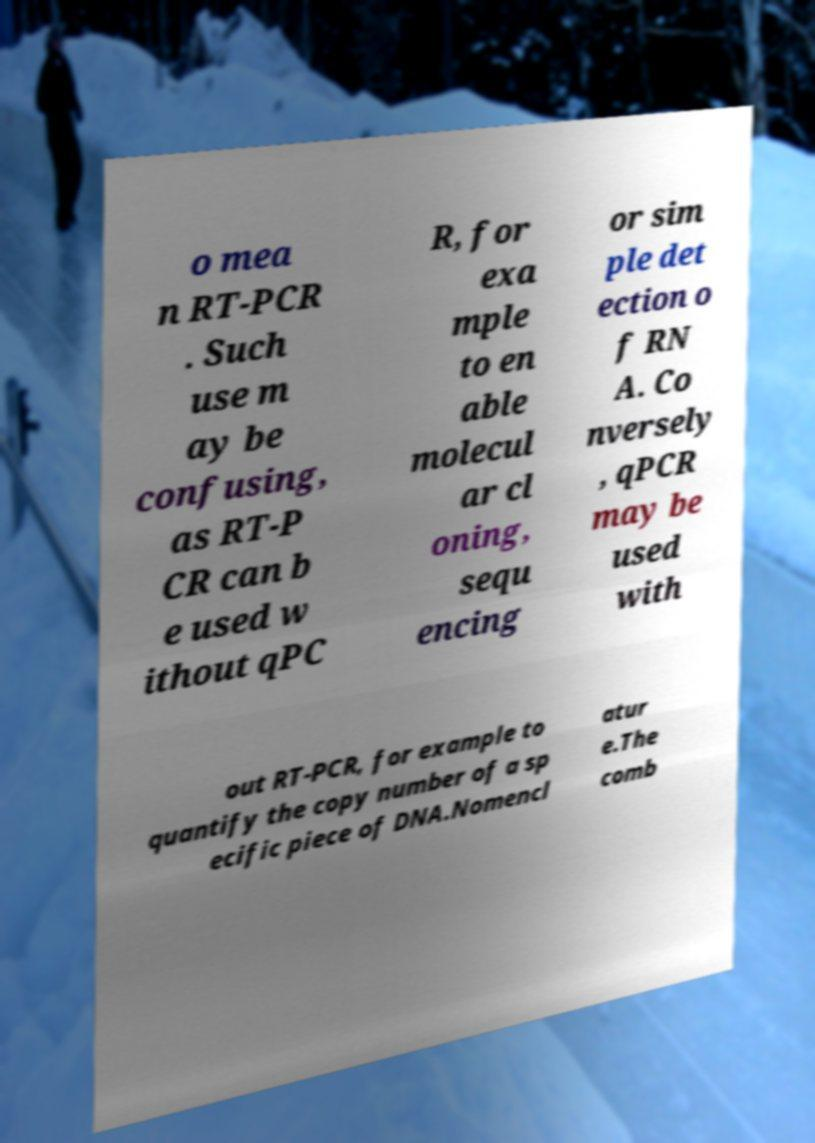Please identify and transcribe the text found in this image. o mea n RT-PCR . Such use m ay be confusing, as RT-P CR can b e used w ithout qPC R, for exa mple to en able molecul ar cl oning, sequ encing or sim ple det ection o f RN A. Co nversely , qPCR may be used with out RT-PCR, for example to quantify the copy number of a sp ecific piece of DNA.Nomencl atur e.The comb 